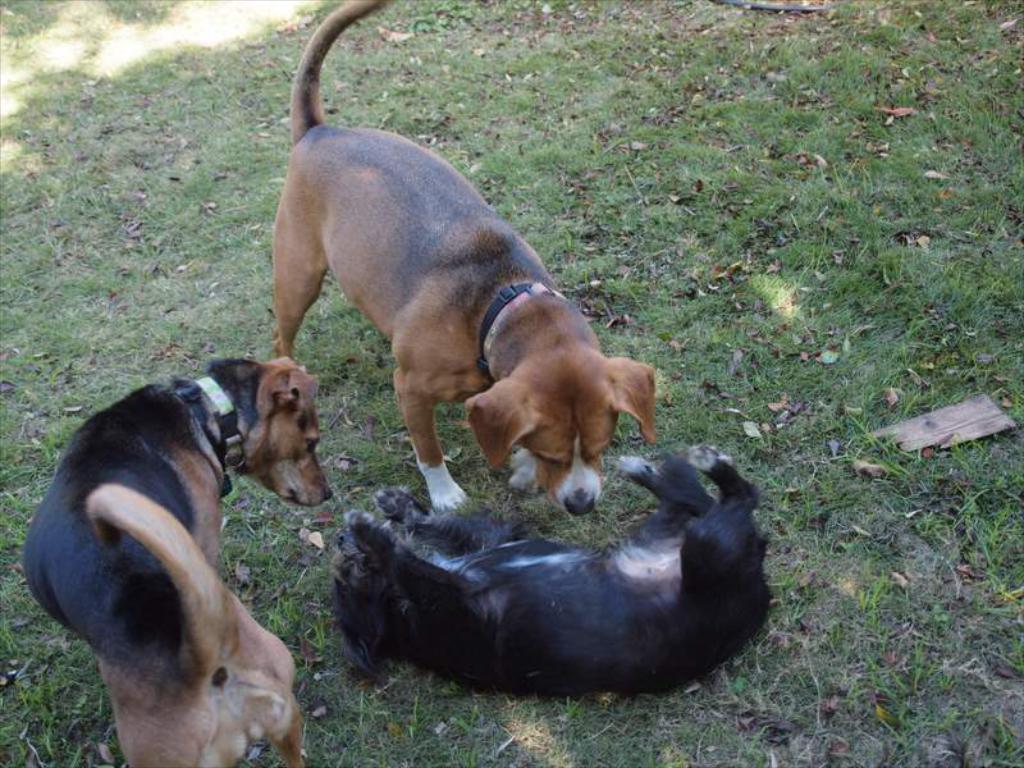Can you describe this image briefly? In the picture I can see three dogs among them one is lying on the ground. These dogs are wearing neck belts. I can also see the grass. 